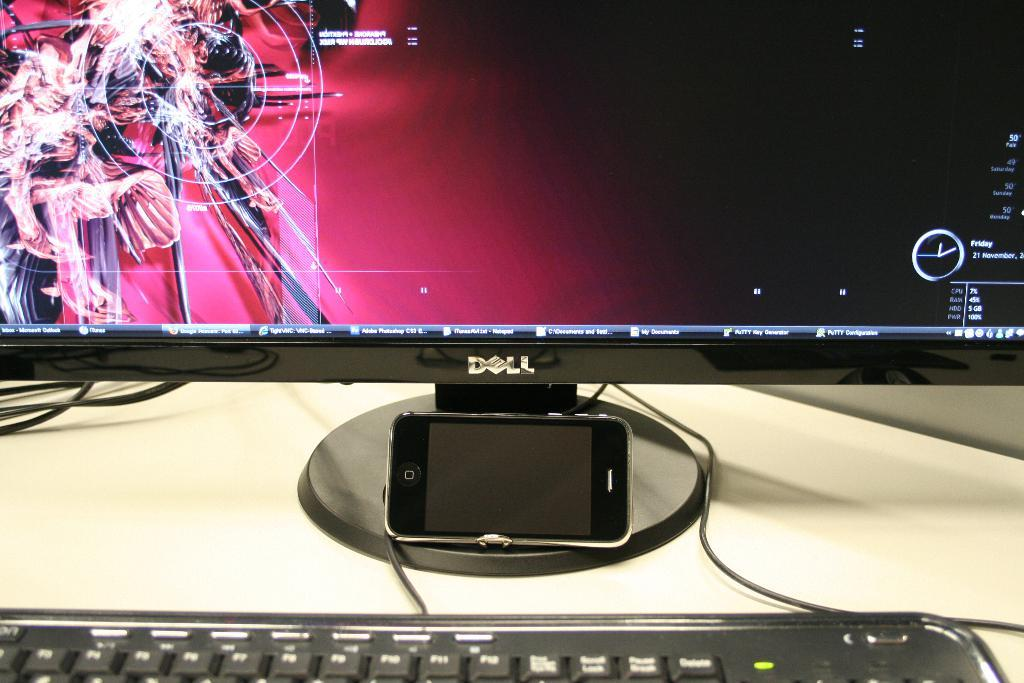<image>
Relay a brief, clear account of the picture shown. The black monitor has the brand name dell on it 